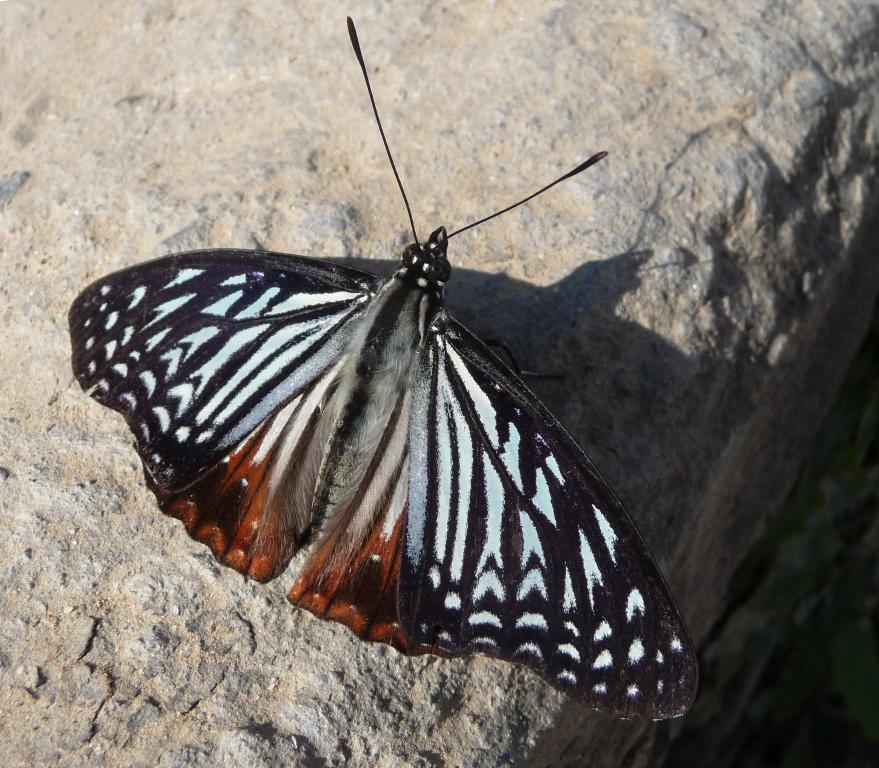What is the main subject of the image? There is a butterfly in the image. Where is the butterfly located? The butterfly is on a wall. What color is the background of the image? The background of the image is gray in color. Can you see any blood on the butterfly in the image? No, there is no blood visible on the butterfly in the image. 